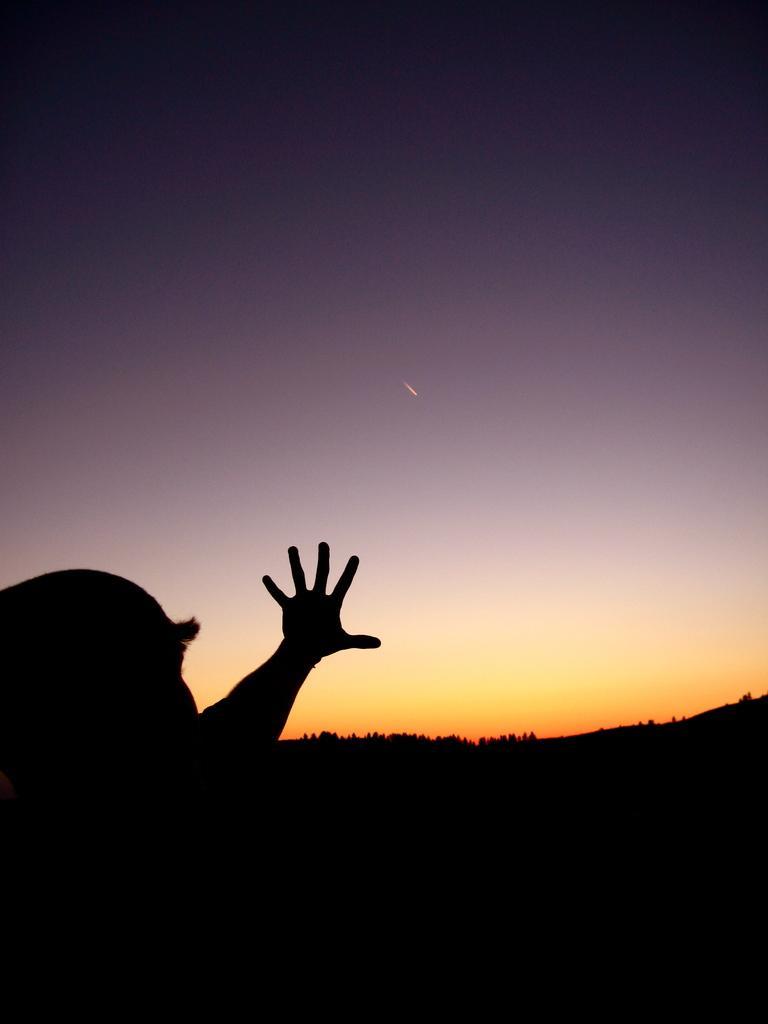In one or two sentences, can you explain what this image depicts? In this picture we can see a person and behind the person there are trees and the sky. 